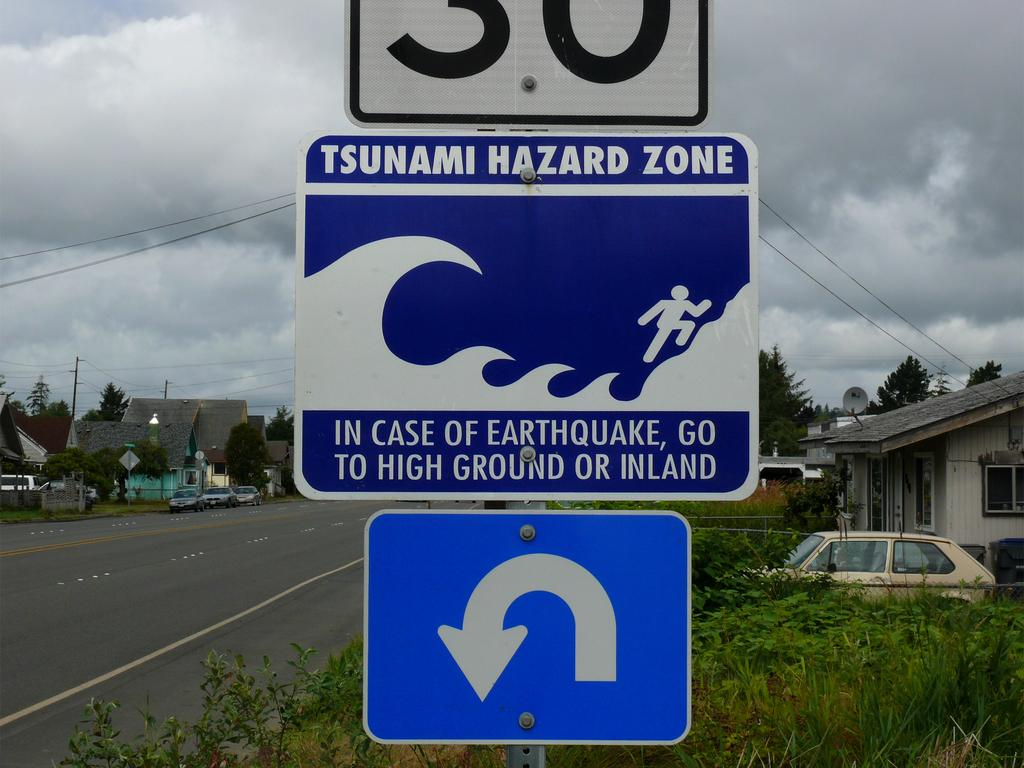<image>
Relay a brief, clear account of the picture shown. A blue and white sign with the words Tsunami Hazard Zone on top and houses in the background. 